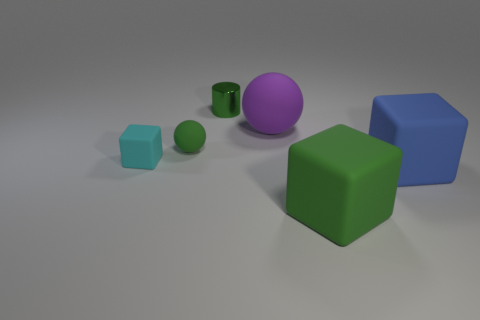What is the big purple sphere behind the big green rubber cube made of?
Offer a very short reply. Rubber. Is the shape of the cyan object the same as the large blue thing?
Provide a succinct answer. Yes. What is the color of the block to the left of the big matte thing behind the matte cube that is on the left side of the large green matte thing?
Offer a very short reply. Cyan. How many tiny cyan matte things have the same shape as the small metallic object?
Offer a very short reply. 0. What is the size of the green matte thing in front of the ball in front of the purple sphere?
Offer a very short reply. Large. Is the size of the cylinder the same as the green cube?
Your answer should be compact. No. There is a rubber ball to the right of the green thing that is behind the large ball; are there any big rubber balls behind it?
Your answer should be very brief. No. What is the size of the green block?
Make the answer very short. Large. What number of cyan blocks have the same size as the green rubber ball?
Provide a succinct answer. 1. There is a small object that is the same shape as the big purple matte object; what material is it?
Offer a terse response. Rubber. 